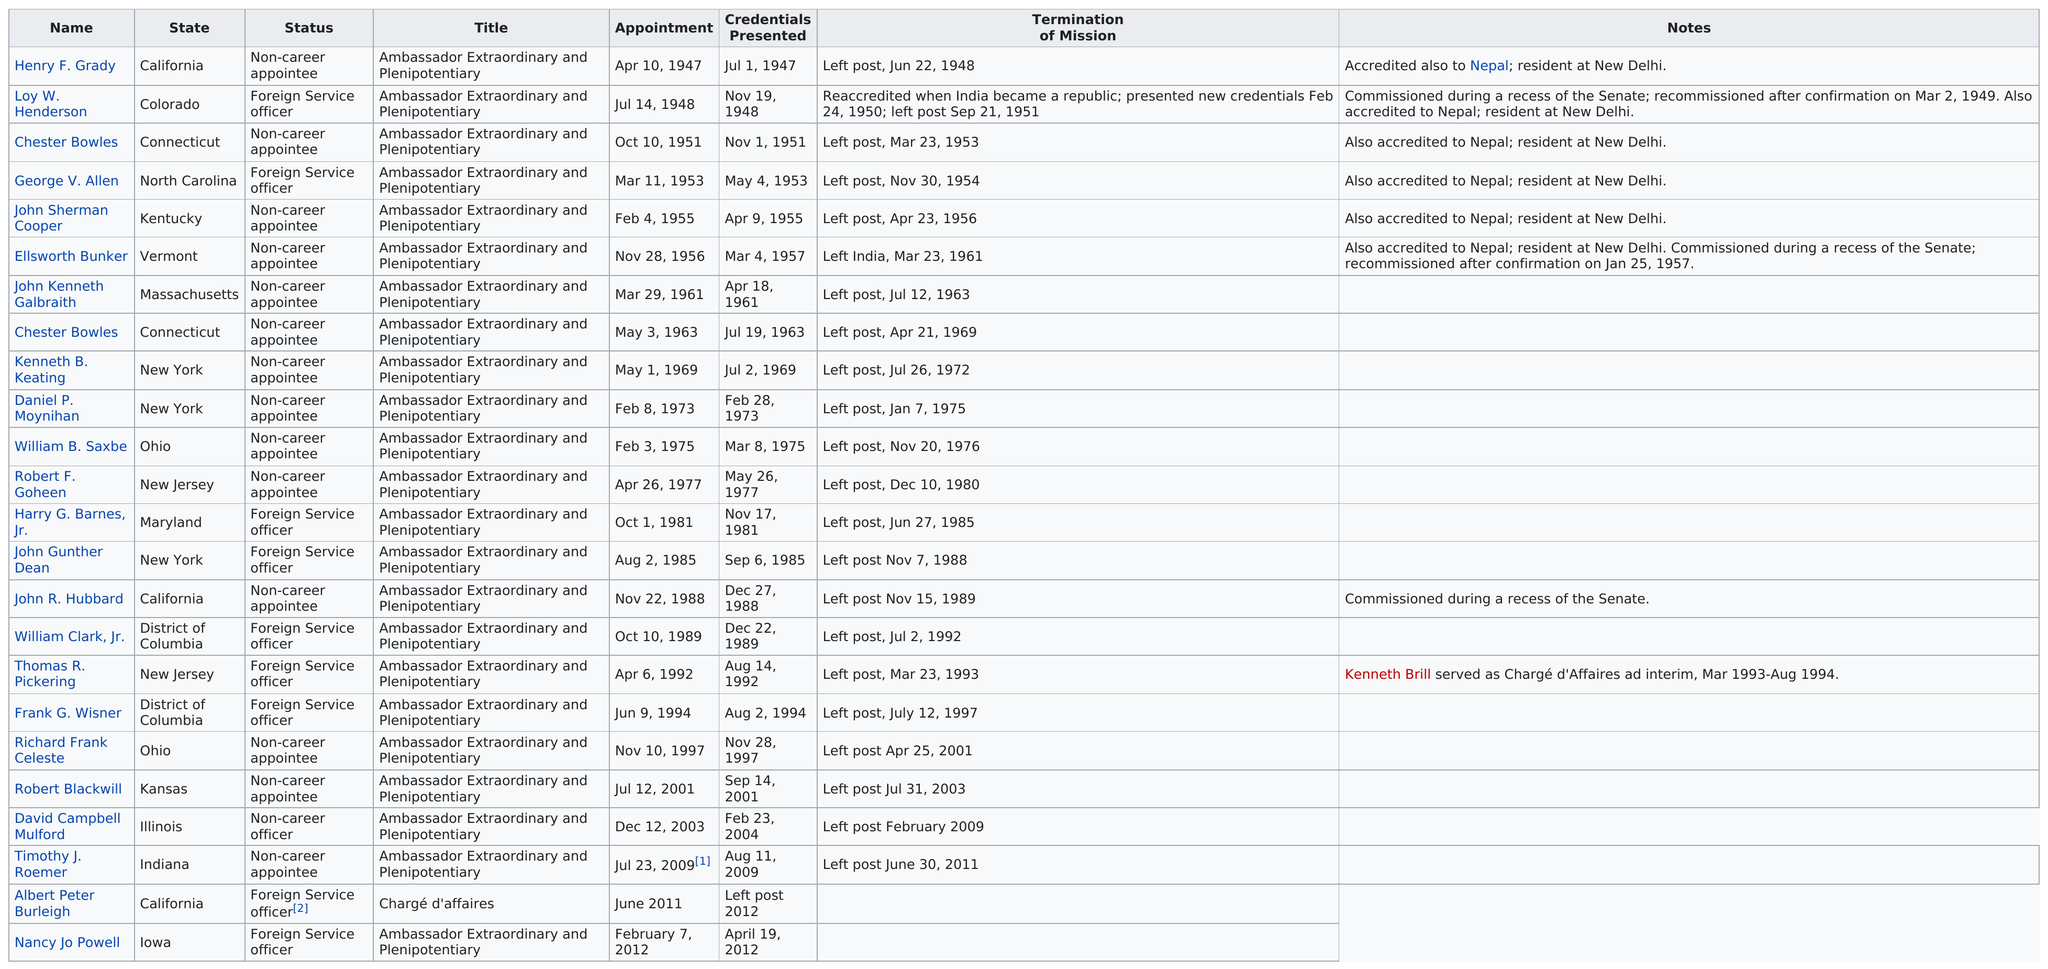Point out several critical features in this image. Albert Peter Burleigh is the only person listed with the title of chargé d'affaires. The list of chiefs who are foreign service officers includes a total of 9 individuals. The first ambassador extraordinary and plenipotentiary to serve in this millennium was Robert Blackwill. Harry G. Barnes, Jr. served as an ambassador after 1980 and served for more than three years. He also lived on the east coast. George V. Allen was the only chief of mission from North Carolina to India. 